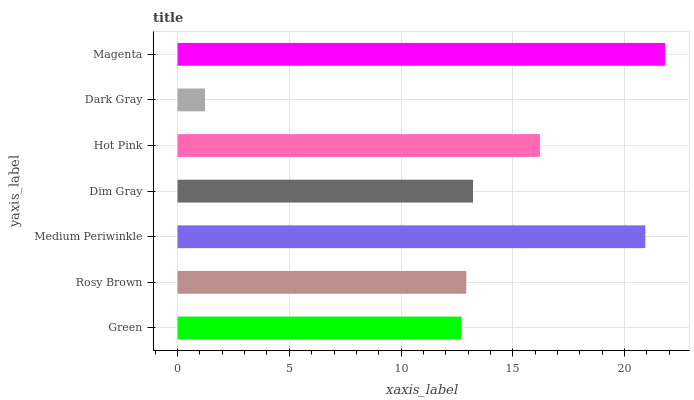Is Dark Gray the minimum?
Answer yes or no. Yes. Is Magenta the maximum?
Answer yes or no. Yes. Is Rosy Brown the minimum?
Answer yes or no. No. Is Rosy Brown the maximum?
Answer yes or no. No. Is Rosy Brown greater than Green?
Answer yes or no. Yes. Is Green less than Rosy Brown?
Answer yes or no. Yes. Is Green greater than Rosy Brown?
Answer yes or no. No. Is Rosy Brown less than Green?
Answer yes or no. No. Is Dim Gray the high median?
Answer yes or no. Yes. Is Dim Gray the low median?
Answer yes or no. Yes. Is Green the high median?
Answer yes or no. No. Is Dark Gray the low median?
Answer yes or no. No. 